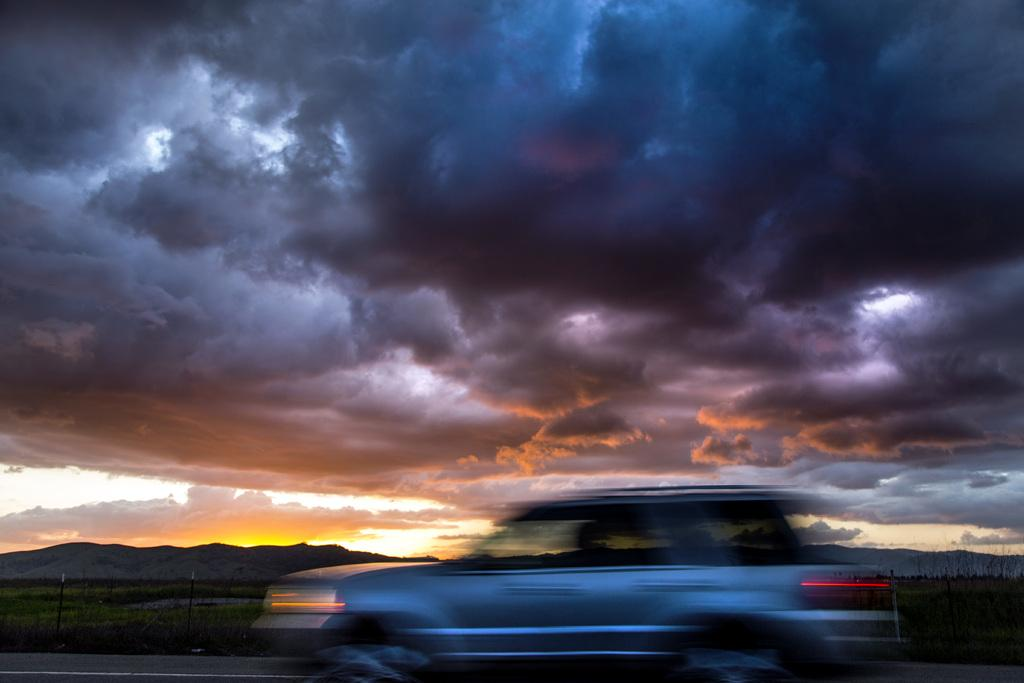What is the main subject of the image? The main subject of the image is a car. What is the car doing in the image? The car is moving on the road in the image. What can be seen in the background of the image? In the background of the image, there is a mountain, trees, plants, grass, and the sky. What is the condition of the sky in the image? The sky is visible at the top of the image, and clouds are present in the sky. Where is the throne located in the image? There is no throne present in the image. What type of flowers can be seen growing near the car in the image? There are no flowers visible in the image; only the car, road, and background elements are present. 